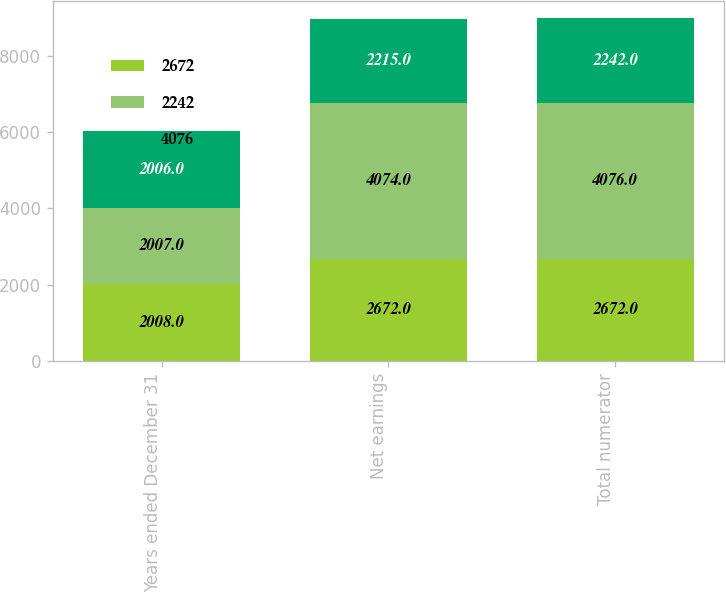Convert chart. <chart><loc_0><loc_0><loc_500><loc_500><stacked_bar_chart><ecel><fcel>Years ended December 31<fcel>Net earnings<fcel>Total numerator<nl><fcel>2672<fcel>2008<fcel>2672<fcel>2672<nl><fcel>2242<fcel>2007<fcel>4074<fcel>4076<nl><fcel>4076<fcel>2006<fcel>2215<fcel>2242<nl></chart> 